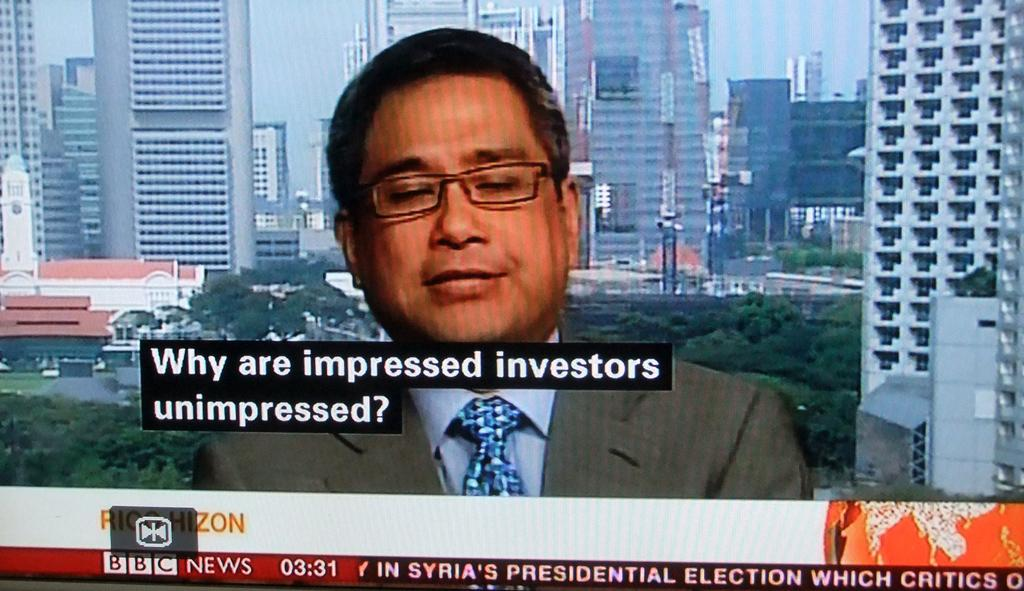What is the main subject of the image? There is an advertisement in the image. Can you describe the advertisement? Unfortunately, the provided facts do not include any details about the advertisement. Is there any text or images on the advertisement? The provided facts do not specify any text or images on the advertisement. What color is the owner's notebook in the image? There is no owner or notebook present in the image. What is the mass of the object being advertised in the image? The provided facts do not include any information about the object being advertised, so we cannot determine its mass. 